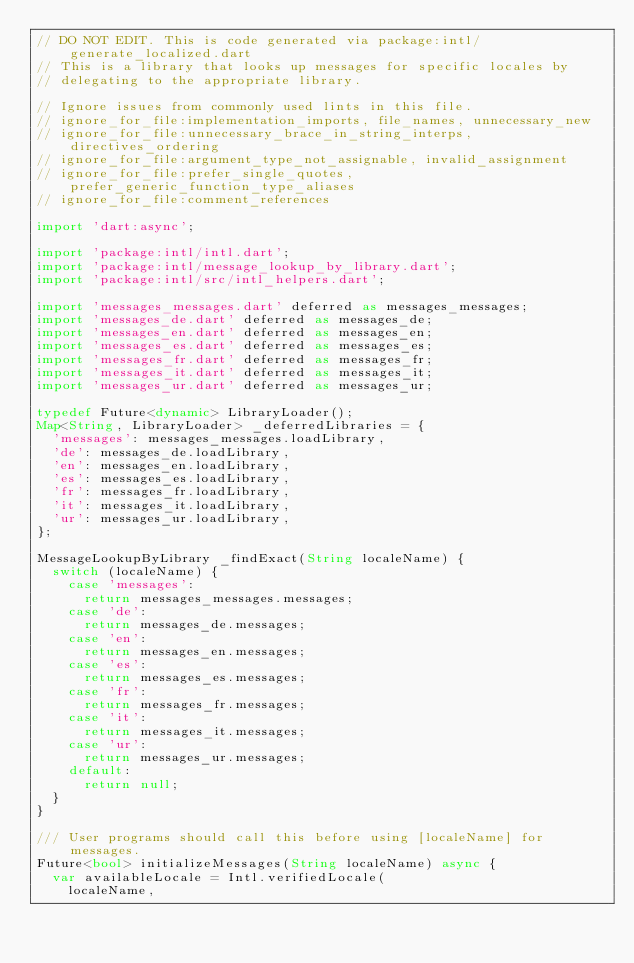Convert code to text. <code><loc_0><loc_0><loc_500><loc_500><_Dart_>// DO NOT EDIT. This is code generated via package:intl/generate_localized.dart
// This is a library that looks up messages for specific locales by
// delegating to the appropriate library.

// Ignore issues from commonly used lints in this file.
// ignore_for_file:implementation_imports, file_names, unnecessary_new
// ignore_for_file:unnecessary_brace_in_string_interps, directives_ordering
// ignore_for_file:argument_type_not_assignable, invalid_assignment
// ignore_for_file:prefer_single_quotes, prefer_generic_function_type_aliases
// ignore_for_file:comment_references

import 'dart:async';

import 'package:intl/intl.dart';
import 'package:intl/message_lookup_by_library.dart';
import 'package:intl/src/intl_helpers.dart';

import 'messages_messages.dart' deferred as messages_messages;
import 'messages_de.dart' deferred as messages_de;
import 'messages_en.dart' deferred as messages_en;
import 'messages_es.dart' deferred as messages_es;
import 'messages_fr.dart' deferred as messages_fr;
import 'messages_it.dart' deferred as messages_it;
import 'messages_ur.dart' deferred as messages_ur;

typedef Future<dynamic> LibraryLoader();
Map<String, LibraryLoader> _deferredLibraries = {
  'messages': messages_messages.loadLibrary,
  'de': messages_de.loadLibrary,
  'en': messages_en.loadLibrary,
  'es': messages_es.loadLibrary,
  'fr': messages_fr.loadLibrary,
  'it': messages_it.loadLibrary,
  'ur': messages_ur.loadLibrary,
};

MessageLookupByLibrary _findExact(String localeName) {
  switch (localeName) {
    case 'messages':
      return messages_messages.messages;
    case 'de':
      return messages_de.messages;
    case 'en':
      return messages_en.messages;
    case 'es':
      return messages_es.messages;
    case 'fr':
      return messages_fr.messages;
    case 'it':
      return messages_it.messages;
    case 'ur':
      return messages_ur.messages;
    default:
      return null;
  }
}

/// User programs should call this before using [localeName] for messages.
Future<bool> initializeMessages(String localeName) async {
  var availableLocale = Intl.verifiedLocale(
    localeName,</code> 